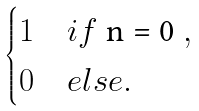<formula> <loc_0><loc_0><loc_500><loc_500>\begin{cases} 1 & i f $ n = 0 $ , \\ 0 & e l s e . \end{cases}</formula> 